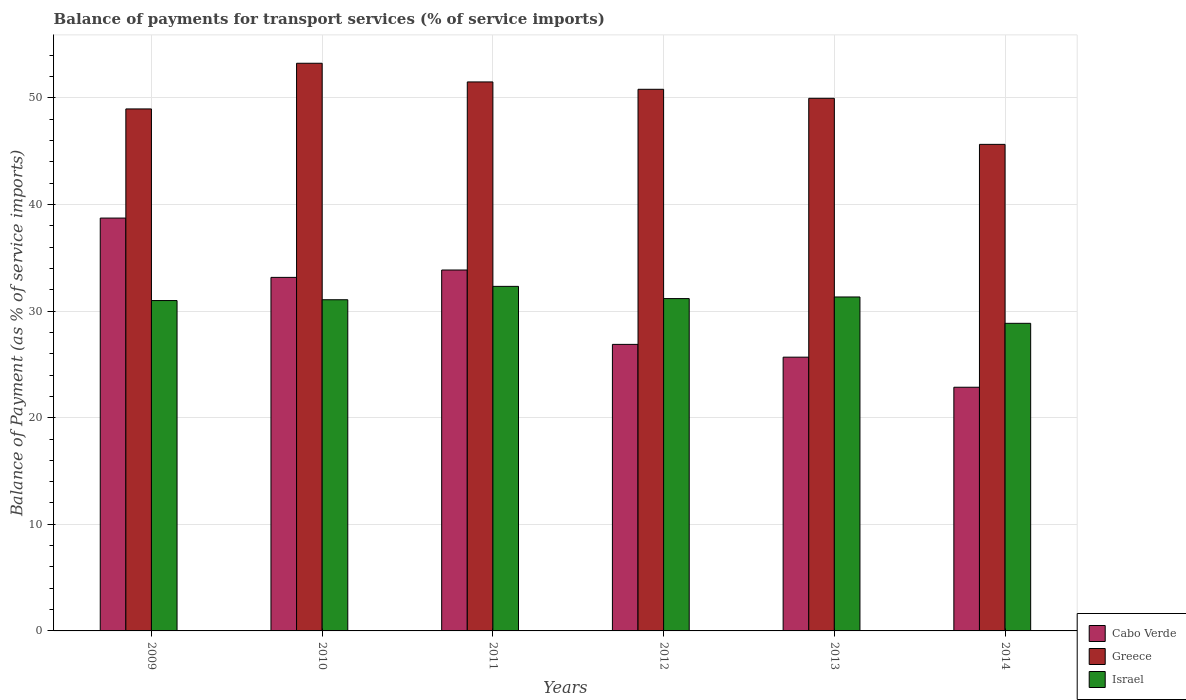How many different coloured bars are there?
Your answer should be very brief. 3. Are the number of bars per tick equal to the number of legend labels?
Your answer should be compact. Yes. What is the label of the 1st group of bars from the left?
Give a very brief answer. 2009. What is the balance of payments for transport services in Israel in 2014?
Provide a succinct answer. 28.85. Across all years, what is the maximum balance of payments for transport services in Cabo Verde?
Ensure brevity in your answer.  38.73. Across all years, what is the minimum balance of payments for transport services in Cabo Verde?
Provide a short and direct response. 22.86. In which year was the balance of payments for transport services in Greece maximum?
Make the answer very short. 2010. In which year was the balance of payments for transport services in Cabo Verde minimum?
Give a very brief answer. 2014. What is the total balance of payments for transport services in Greece in the graph?
Provide a succinct answer. 300.13. What is the difference between the balance of payments for transport services in Greece in 2013 and that in 2014?
Offer a terse response. 4.32. What is the difference between the balance of payments for transport services in Cabo Verde in 2011 and the balance of payments for transport services in Israel in 2014?
Your answer should be compact. 5. What is the average balance of payments for transport services in Cabo Verde per year?
Your answer should be compact. 30.19. In the year 2009, what is the difference between the balance of payments for transport services in Greece and balance of payments for transport services in Cabo Verde?
Offer a very short reply. 10.24. In how many years, is the balance of payments for transport services in Israel greater than 38 %?
Offer a terse response. 0. What is the ratio of the balance of payments for transport services in Greece in 2011 to that in 2014?
Your answer should be compact. 1.13. Is the balance of payments for transport services in Cabo Verde in 2009 less than that in 2011?
Ensure brevity in your answer.  No. What is the difference between the highest and the second highest balance of payments for transport services in Israel?
Give a very brief answer. 1. What is the difference between the highest and the lowest balance of payments for transport services in Israel?
Provide a succinct answer. 3.47. What does the 3rd bar from the right in 2013 represents?
Your answer should be compact. Cabo Verde. How many bars are there?
Your answer should be compact. 18. Are all the bars in the graph horizontal?
Give a very brief answer. No. What is the difference between two consecutive major ticks on the Y-axis?
Your answer should be very brief. 10. Does the graph contain grids?
Ensure brevity in your answer.  Yes. What is the title of the graph?
Your answer should be compact. Balance of payments for transport services (% of service imports). Does "Channel Islands" appear as one of the legend labels in the graph?
Make the answer very short. No. What is the label or title of the Y-axis?
Give a very brief answer. Balance of Payment (as % of service imports). What is the Balance of Payment (as % of service imports) in Cabo Verde in 2009?
Keep it short and to the point. 38.73. What is the Balance of Payment (as % of service imports) in Greece in 2009?
Keep it short and to the point. 48.97. What is the Balance of Payment (as % of service imports) of Israel in 2009?
Your answer should be very brief. 30.99. What is the Balance of Payment (as % of service imports) of Cabo Verde in 2010?
Offer a terse response. 33.16. What is the Balance of Payment (as % of service imports) of Greece in 2010?
Your response must be concise. 53.25. What is the Balance of Payment (as % of service imports) of Israel in 2010?
Your answer should be compact. 31.07. What is the Balance of Payment (as % of service imports) of Cabo Verde in 2011?
Offer a very short reply. 33.86. What is the Balance of Payment (as % of service imports) in Greece in 2011?
Your response must be concise. 51.5. What is the Balance of Payment (as % of service imports) in Israel in 2011?
Give a very brief answer. 32.32. What is the Balance of Payment (as % of service imports) in Cabo Verde in 2012?
Make the answer very short. 26.88. What is the Balance of Payment (as % of service imports) of Greece in 2012?
Provide a succinct answer. 50.81. What is the Balance of Payment (as % of service imports) of Israel in 2012?
Provide a succinct answer. 31.18. What is the Balance of Payment (as % of service imports) of Cabo Verde in 2013?
Provide a short and direct response. 25.68. What is the Balance of Payment (as % of service imports) of Greece in 2013?
Your response must be concise. 49.96. What is the Balance of Payment (as % of service imports) in Israel in 2013?
Make the answer very short. 31.33. What is the Balance of Payment (as % of service imports) in Cabo Verde in 2014?
Offer a terse response. 22.86. What is the Balance of Payment (as % of service imports) in Greece in 2014?
Make the answer very short. 45.64. What is the Balance of Payment (as % of service imports) in Israel in 2014?
Make the answer very short. 28.85. Across all years, what is the maximum Balance of Payment (as % of service imports) of Cabo Verde?
Provide a succinct answer. 38.73. Across all years, what is the maximum Balance of Payment (as % of service imports) in Greece?
Give a very brief answer. 53.25. Across all years, what is the maximum Balance of Payment (as % of service imports) of Israel?
Provide a short and direct response. 32.32. Across all years, what is the minimum Balance of Payment (as % of service imports) in Cabo Verde?
Keep it short and to the point. 22.86. Across all years, what is the minimum Balance of Payment (as % of service imports) of Greece?
Your answer should be very brief. 45.64. Across all years, what is the minimum Balance of Payment (as % of service imports) of Israel?
Provide a short and direct response. 28.85. What is the total Balance of Payment (as % of service imports) in Cabo Verde in the graph?
Ensure brevity in your answer.  181.17. What is the total Balance of Payment (as % of service imports) in Greece in the graph?
Offer a very short reply. 300.13. What is the total Balance of Payment (as % of service imports) in Israel in the graph?
Make the answer very short. 185.74. What is the difference between the Balance of Payment (as % of service imports) of Cabo Verde in 2009 and that in 2010?
Provide a short and direct response. 5.56. What is the difference between the Balance of Payment (as % of service imports) of Greece in 2009 and that in 2010?
Make the answer very short. -4.28. What is the difference between the Balance of Payment (as % of service imports) of Israel in 2009 and that in 2010?
Offer a very short reply. -0.08. What is the difference between the Balance of Payment (as % of service imports) in Cabo Verde in 2009 and that in 2011?
Give a very brief answer. 4.87. What is the difference between the Balance of Payment (as % of service imports) of Greece in 2009 and that in 2011?
Keep it short and to the point. -2.53. What is the difference between the Balance of Payment (as % of service imports) of Israel in 2009 and that in 2011?
Provide a short and direct response. -1.33. What is the difference between the Balance of Payment (as % of service imports) in Cabo Verde in 2009 and that in 2012?
Provide a short and direct response. 11.85. What is the difference between the Balance of Payment (as % of service imports) of Greece in 2009 and that in 2012?
Your response must be concise. -1.84. What is the difference between the Balance of Payment (as % of service imports) of Israel in 2009 and that in 2012?
Your answer should be compact. -0.18. What is the difference between the Balance of Payment (as % of service imports) of Cabo Verde in 2009 and that in 2013?
Offer a very short reply. 13.05. What is the difference between the Balance of Payment (as % of service imports) of Greece in 2009 and that in 2013?
Make the answer very short. -1. What is the difference between the Balance of Payment (as % of service imports) in Israel in 2009 and that in 2013?
Provide a short and direct response. -0.34. What is the difference between the Balance of Payment (as % of service imports) in Cabo Verde in 2009 and that in 2014?
Give a very brief answer. 15.87. What is the difference between the Balance of Payment (as % of service imports) of Greece in 2009 and that in 2014?
Provide a short and direct response. 3.32. What is the difference between the Balance of Payment (as % of service imports) of Israel in 2009 and that in 2014?
Your answer should be very brief. 2.14. What is the difference between the Balance of Payment (as % of service imports) in Cabo Verde in 2010 and that in 2011?
Give a very brief answer. -0.69. What is the difference between the Balance of Payment (as % of service imports) in Greece in 2010 and that in 2011?
Offer a very short reply. 1.75. What is the difference between the Balance of Payment (as % of service imports) in Israel in 2010 and that in 2011?
Keep it short and to the point. -1.25. What is the difference between the Balance of Payment (as % of service imports) of Cabo Verde in 2010 and that in 2012?
Keep it short and to the point. 6.28. What is the difference between the Balance of Payment (as % of service imports) of Greece in 2010 and that in 2012?
Your response must be concise. 2.44. What is the difference between the Balance of Payment (as % of service imports) in Israel in 2010 and that in 2012?
Offer a very short reply. -0.11. What is the difference between the Balance of Payment (as % of service imports) of Cabo Verde in 2010 and that in 2013?
Offer a terse response. 7.48. What is the difference between the Balance of Payment (as % of service imports) in Greece in 2010 and that in 2013?
Provide a succinct answer. 3.29. What is the difference between the Balance of Payment (as % of service imports) in Israel in 2010 and that in 2013?
Provide a short and direct response. -0.26. What is the difference between the Balance of Payment (as % of service imports) in Cabo Verde in 2010 and that in 2014?
Your answer should be very brief. 10.31. What is the difference between the Balance of Payment (as % of service imports) in Greece in 2010 and that in 2014?
Provide a short and direct response. 7.61. What is the difference between the Balance of Payment (as % of service imports) of Israel in 2010 and that in 2014?
Your answer should be compact. 2.21. What is the difference between the Balance of Payment (as % of service imports) of Cabo Verde in 2011 and that in 2012?
Offer a very short reply. 6.98. What is the difference between the Balance of Payment (as % of service imports) in Greece in 2011 and that in 2012?
Make the answer very short. 0.69. What is the difference between the Balance of Payment (as % of service imports) of Israel in 2011 and that in 2012?
Keep it short and to the point. 1.15. What is the difference between the Balance of Payment (as % of service imports) in Cabo Verde in 2011 and that in 2013?
Provide a succinct answer. 8.18. What is the difference between the Balance of Payment (as % of service imports) of Greece in 2011 and that in 2013?
Provide a succinct answer. 1.54. What is the difference between the Balance of Payment (as % of service imports) of Israel in 2011 and that in 2013?
Provide a short and direct response. 1. What is the difference between the Balance of Payment (as % of service imports) in Cabo Verde in 2011 and that in 2014?
Keep it short and to the point. 11. What is the difference between the Balance of Payment (as % of service imports) of Greece in 2011 and that in 2014?
Offer a terse response. 5.86. What is the difference between the Balance of Payment (as % of service imports) in Israel in 2011 and that in 2014?
Your response must be concise. 3.47. What is the difference between the Balance of Payment (as % of service imports) of Cabo Verde in 2012 and that in 2013?
Provide a succinct answer. 1.2. What is the difference between the Balance of Payment (as % of service imports) in Greece in 2012 and that in 2013?
Keep it short and to the point. 0.85. What is the difference between the Balance of Payment (as % of service imports) in Israel in 2012 and that in 2013?
Make the answer very short. -0.15. What is the difference between the Balance of Payment (as % of service imports) of Cabo Verde in 2012 and that in 2014?
Your response must be concise. 4.02. What is the difference between the Balance of Payment (as % of service imports) in Greece in 2012 and that in 2014?
Keep it short and to the point. 5.17. What is the difference between the Balance of Payment (as % of service imports) in Israel in 2012 and that in 2014?
Offer a very short reply. 2.32. What is the difference between the Balance of Payment (as % of service imports) of Cabo Verde in 2013 and that in 2014?
Ensure brevity in your answer.  2.82. What is the difference between the Balance of Payment (as % of service imports) of Greece in 2013 and that in 2014?
Your answer should be very brief. 4.32. What is the difference between the Balance of Payment (as % of service imports) of Israel in 2013 and that in 2014?
Offer a terse response. 2.47. What is the difference between the Balance of Payment (as % of service imports) of Cabo Verde in 2009 and the Balance of Payment (as % of service imports) of Greece in 2010?
Keep it short and to the point. -14.52. What is the difference between the Balance of Payment (as % of service imports) of Cabo Verde in 2009 and the Balance of Payment (as % of service imports) of Israel in 2010?
Keep it short and to the point. 7.66. What is the difference between the Balance of Payment (as % of service imports) in Greece in 2009 and the Balance of Payment (as % of service imports) in Israel in 2010?
Provide a succinct answer. 17.9. What is the difference between the Balance of Payment (as % of service imports) in Cabo Verde in 2009 and the Balance of Payment (as % of service imports) in Greece in 2011?
Give a very brief answer. -12.77. What is the difference between the Balance of Payment (as % of service imports) of Cabo Verde in 2009 and the Balance of Payment (as % of service imports) of Israel in 2011?
Your answer should be very brief. 6.41. What is the difference between the Balance of Payment (as % of service imports) in Greece in 2009 and the Balance of Payment (as % of service imports) in Israel in 2011?
Provide a succinct answer. 16.64. What is the difference between the Balance of Payment (as % of service imports) in Cabo Verde in 2009 and the Balance of Payment (as % of service imports) in Greece in 2012?
Your response must be concise. -12.08. What is the difference between the Balance of Payment (as % of service imports) in Cabo Verde in 2009 and the Balance of Payment (as % of service imports) in Israel in 2012?
Keep it short and to the point. 7.55. What is the difference between the Balance of Payment (as % of service imports) of Greece in 2009 and the Balance of Payment (as % of service imports) of Israel in 2012?
Keep it short and to the point. 17.79. What is the difference between the Balance of Payment (as % of service imports) of Cabo Verde in 2009 and the Balance of Payment (as % of service imports) of Greece in 2013?
Offer a terse response. -11.24. What is the difference between the Balance of Payment (as % of service imports) in Cabo Verde in 2009 and the Balance of Payment (as % of service imports) in Israel in 2013?
Keep it short and to the point. 7.4. What is the difference between the Balance of Payment (as % of service imports) of Greece in 2009 and the Balance of Payment (as % of service imports) of Israel in 2013?
Ensure brevity in your answer.  17.64. What is the difference between the Balance of Payment (as % of service imports) of Cabo Verde in 2009 and the Balance of Payment (as % of service imports) of Greece in 2014?
Make the answer very short. -6.91. What is the difference between the Balance of Payment (as % of service imports) of Cabo Verde in 2009 and the Balance of Payment (as % of service imports) of Israel in 2014?
Keep it short and to the point. 9.87. What is the difference between the Balance of Payment (as % of service imports) in Greece in 2009 and the Balance of Payment (as % of service imports) in Israel in 2014?
Your response must be concise. 20.11. What is the difference between the Balance of Payment (as % of service imports) of Cabo Verde in 2010 and the Balance of Payment (as % of service imports) of Greece in 2011?
Make the answer very short. -18.33. What is the difference between the Balance of Payment (as % of service imports) in Cabo Verde in 2010 and the Balance of Payment (as % of service imports) in Israel in 2011?
Your answer should be compact. 0.84. What is the difference between the Balance of Payment (as % of service imports) of Greece in 2010 and the Balance of Payment (as % of service imports) of Israel in 2011?
Keep it short and to the point. 20.93. What is the difference between the Balance of Payment (as % of service imports) in Cabo Verde in 2010 and the Balance of Payment (as % of service imports) in Greece in 2012?
Make the answer very short. -17.64. What is the difference between the Balance of Payment (as % of service imports) of Cabo Verde in 2010 and the Balance of Payment (as % of service imports) of Israel in 2012?
Your answer should be very brief. 1.99. What is the difference between the Balance of Payment (as % of service imports) of Greece in 2010 and the Balance of Payment (as % of service imports) of Israel in 2012?
Keep it short and to the point. 22.08. What is the difference between the Balance of Payment (as % of service imports) in Cabo Verde in 2010 and the Balance of Payment (as % of service imports) in Greece in 2013?
Your answer should be compact. -16.8. What is the difference between the Balance of Payment (as % of service imports) in Cabo Verde in 2010 and the Balance of Payment (as % of service imports) in Israel in 2013?
Keep it short and to the point. 1.84. What is the difference between the Balance of Payment (as % of service imports) of Greece in 2010 and the Balance of Payment (as % of service imports) of Israel in 2013?
Your answer should be compact. 21.92. What is the difference between the Balance of Payment (as % of service imports) of Cabo Verde in 2010 and the Balance of Payment (as % of service imports) of Greece in 2014?
Your answer should be very brief. -12.48. What is the difference between the Balance of Payment (as % of service imports) of Cabo Verde in 2010 and the Balance of Payment (as % of service imports) of Israel in 2014?
Keep it short and to the point. 4.31. What is the difference between the Balance of Payment (as % of service imports) of Greece in 2010 and the Balance of Payment (as % of service imports) of Israel in 2014?
Your response must be concise. 24.4. What is the difference between the Balance of Payment (as % of service imports) of Cabo Verde in 2011 and the Balance of Payment (as % of service imports) of Greece in 2012?
Make the answer very short. -16.95. What is the difference between the Balance of Payment (as % of service imports) in Cabo Verde in 2011 and the Balance of Payment (as % of service imports) in Israel in 2012?
Provide a short and direct response. 2.68. What is the difference between the Balance of Payment (as % of service imports) in Greece in 2011 and the Balance of Payment (as % of service imports) in Israel in 2012?
Offer a very short reply. 20.32. What is the difference between the Balance of Payment (as % of service imports) in Cabo Verde in 2011 and the Balance of Payment (as % of service imports) in Greece in 2013?
Give a very brief answer. -16.11. What is the difference between the Balance of Payment (as % of service imports) in Cabo Verde in 2011 and the Balance of Payment (as % of service imports) in Israel in 2013?
Your answer should be compact. 2.53. What is the difference between the Balance of Payment (as % of service imports) of Greece in 2011 and the Balance of Payment (as % of service imports) of Israel in 2013?
Make the answer very short. 20.17. What is the difference between the Balance of Payment (as % of service imports) of Cabo Verde in 2011 and the Balance of Payment (as % of service imports) of Greece in 2014?
Provide a succinct answer. -11.79. What is the difference between the Balance of Payment (as % of service imports) in Cabo Verde in 2011 and the Balance of Payment (as % of service imports) in Israel in 2014?
Ensure brevity in your answer.  5. What is the difference between the Balance of Payment (as % of service imports) in Greece in 2011 and the Balance of Payment (as % of service imports) in Israel in 2014?
Ensure brevity in your answer.  22.64. What is the difference between the Balance of Payment (as % of service imports) of Cabo Verde in 2012 and the Balance of Payment (as % of service imports) of Greece in 2013?
Your answer should be very brief. -23.08. What is the difference between the Balance of Payment (as % of service imports) in Cabo Verde in 2012 and the Balance of Payment (as % of service imports) in Israel in 2013?
Your answer should be very brief. -4.45. What is the difference between the Balance of Payment (as % of service imports) in Greece in 2012 and the Balance of Payment (as % of service imports) in Israel in 2013?
Provide a succinct answer. 19.48. What is the difference between the Balance of Payment (as % of service imports) in Cabo Verde in 2012 and the Balance of Payment (as % of service imports) in Greece in 2014?
Provide a succinct answer. -18.76. What is the difference between the Balance of Payment (as % of service imports) of Cabo Verde in 2012 and the Balance of Payment (as % of service imports) of Israel in 2014?
Your answer should be very brief. -1.97. What is the difference between the Balance of Payment (as % of service imports) in Greece in 2012 and the Balance of Payment (as % of service imports) in Israel in 2014?
Ensure brevity in your answer.  21.95. What is the difference between the Balance of Payment (as % of service imports) in Cabo Verde in 2013 and the Balance of Payment (as % of service imports) in Greece in 2014?
Provide a short and direct response. -19.96. What is the difference between the Balance of Payment (as % of service imports) of Cabo Verde in 2013 and the Balance of Payment (as % of service imports) of Israel in 2014?
Your response must be concise. -3.17. What is the difference between the Balance of Payment (as % of service imports) of Greece in 2013 and the Balance of Payment (as % of service imports) of Israel in 2014?
Provide a short and direct response. 21.11. What is the average Balance of Payment (as % of service imports) of Cabo Verde per year?
Provide a succinct answer. 30.19. What is the average Balance of Payment (as % of service imports) in Greece per year?
Your answer should be compact. 50.02. What is the average Balance of Payment (as % of service imports) of Israel per year?
Your answer should be compact. 30.96. In the year 2009, what is the difference between the Balance of Payment (as % of service imports) of Cabo Verde and Balance of Payment (as % of service imports) of Greece?
Keep it short and to the point. -10.24. In the year 2009, what is the difference between the Balance of Payment (as % of service imports) in Cabo Verde and Balance of Payment (as % of service imports) in Israel?
Offer a very short reply. 7.74. In the year 2009, what is the difference between the Balance of Payment (as % of service imports) of Greece and Balance of Payment (as % of service imports) of Israel?
Ensure brevity in your answer.  17.98. In the year 2010, what is the difference between the Balance of Payment (as % of service imports) of Cabo Verde and Balance of Payment (as % of service imports) of Greece?
Offer a terse response. -20.09. In the year 2010, what is the difference between the Balance of Payment (as % of service imports) of Cabo Verde and Balance of Payment (as % of service imports) of Israel?
Give a very brief answer. 2.1. In the year 2010, what is the difference between the Balance of Payment (as % of service imports) of Greece and Balance of Payment (as % of service imports) of Israel?
Your response must be concise. 22.18. In the year 2011, what is the difference between the Balance of Payment (as % of service imports) in Cabo Verde and Balance of Payment (as % of service imports) in Greece?
Ensure brevity in your answer.  -17.64. In the year 2011, what is the difference between the Balance of Payment (as % of service imports) in Cabo Verde and Balance of Payment (as % of service imports) in Israel?
Ensure brevity in your answer.  1.53. In the year 2011, what is the difference between the Balance of Payment (as % of service imports) in Greece and Balance of Payment (as % of service imports) in Israel?
Your answer should be compact. 19.18. In the year 2012, what is the difference between the Balance of Payment (as % of service imports) of Cabo Verde and Balance of Payment (as % of service imports) of Greece?
Make the answer very short. -23.93. In the year 2012, what is the difference between the Balance of Payment (as % of service imports) of Cabo Verde and Balance of Payment (as % of service imports) of Israel?
Make the answer very short. -4.3. In the year 2012, what is the difference between the Balance of Payment (as % of service imports) of Greece and Balance of Payment (as % of service imports) of Israel?
Your answer should be very brief. 19.63. In the year 2013, what is the difference between the Balance of Payment (as % of service imports) in Cabo Verde and Balance of Payment (as % of service imports) in Greece?
Give a very brief answer. -24.28. In the year 2013, what is the difference between the Balance of Payment (as % of service imports) of Cabo Verde and Balance of Payment (as % of service imports) of Israel?
Ensure brevity in your answer.  -5.65. In the year 2013, what is the difference between the Balance of Payment (as % of service imports) in Greece and Balance of Payment (as % of service imports) in Israel?
Your answer should be compact. 18.64. In the year 2014, what is the difference between the Balance of Payment (as % of service imports) in Cabo Verde and Balance of Payment (as % of service imports) in Greece?
Your answer should be very brief. -22.78. In the year 2014, what is the difference between the Balance of Payment (as % of service imports) in Cabo Verde and Balance of Payment (as % of service imports) in Israel?
Provide a short and direct response. -6. In the year 2014, what is the difference between the Balance of Payment (as % of service imports) in Greece and Balance of Payment (as % of service imports) in Israel?
Your answer should be very brief. 16.79. What is the ratio of the Balance of Payment (as % of service imports) of Cabo Verde in 2009 to that in 2010?
Make the answer very short. 1.17. What is the ratio of the Balance of Payment (as % of service imports) in Greece in 2009 to that in 2010?
Keep it short and to the point. 0.92. What is the ratio of the Balance of Payment (as % of service imports) of Cabo Verde in 2009 to that in 2011?
Make the answer very short. 1.14. What is the ratio of the Balance of Payment (as % of service imports) of Greece in 2009 to that in 2011?
Provide a short and direct response. 0.95. What is the ratio of the Balance of Payment (as % of service imports) in Israel in 2009 to that in 2011?
Offer a very short reply. 0.96. What is the ratio of the Balance of Payment (as % of service imports) in Cabo Verde in 2009 to that in 2012?
Make the answer very short. 1.44. What is the ratio of the Balance of Payment (as % of service imports) of Greece in 2009 to that in 2012?
Give a very brief answer. 0.96. What is the ratio of the Balance of Payment (as % of service imports) in Cabo Verde in 2009 to that in 2013?
Your answer should be compact. 1.51. What is the ratio of the Balance of Payment (as % of service imports) in Israel in 2009 to that in 2013?
Give a very brief answer. 0.99. What is the ratio of the Balance of Payment (as % of service imports) in Cabo Verde in 2009 to that in 2014?
Give a very brief answer. 1.69. What is the ratio of the Balance of Payment (as % of service imports) in Greece in 2009 to that in 2014?
Ensure brevity in your answer.  1.07. What is the ratio of the Balance of Payment (as % of service imports) of Israel in 2009 to that in 2014?
Provide a succinct answer. 1.07. What is the ratio of the Balance of Payment (as % of service imports) in Cabo Verde in 2010 to that in 2011?
Offer a very short reply. 0.98. What is the ratio of the Balance of Payment (as % of service imports) in Greece in 2010 to that in 2011?
Make the answer very short. 1.03. What is the ratio of the Balance of Payment (as % of service imports) in Israel in 2010 to that in 2011?
Your response must be concise. 0.96. What is the ratio of the Balance of Payment (as % of service imports) in Cabo Verde in 2010 to that in 2012?
Provide a succinct answer. 1.23. What is the ratio of the Balance of Payment (as % of service imports) of Greece in 2010 to that in 2012?
Provide a succinct answer. 1.05. What is the ratio of the Balance of Payment (as % of service imports) in Cabo Verde in 2010 to that in 2013?
Provide a short and direct response. 1.29. What is the ratio of the Balance of Payment (as % of service imports) of Greece in 2010 to that in 2013?
Provide a succinct answer. 1.07. What is the ratio of the Balance of Payment (as % of service imports) in Cabo Verde in 2010 to that in 2014?
Provide a short and direct response. 1.45. What is the ratio of the Balance of Payment (as % of service imports) in Greece in 2010 to that in 2014?
Your response must be concise. 1.17. What is the ratio of the Balance of Payment (as % of service imports) in Israel in 2010 to that in 2014?
Make the answer very short. 1.08. What is the ratio of the Balance of Payment (as % of service imports) of Cabo Verde in 2011 to that in 2012?
Your answer should be very brief. 1.26. What is the ratio of the Balance of Payment (as % of service imports) of Greece in 2011 to that in 2012?
Provide a short and direct response. 1.01. What is the ratio of the Balance of Payment (as % of service imports) in Israel in 2011 to that in 2012?
Offer a very short reply. 1.04. What is the ratio of the Balance of Payment (as % of service imports) of Cabo Verde in 2011 to that in 2013?
Provide a succinct answer. 1.32. What is the ratio of the Balance of Payment (as % of service imports) in Greece in 2011 to that in 2013?
Provide a short and direct response. 1.03. What is the ratio of the Balance of Payment (as % of service imports) in Israel in 2011 to that in 2013?
Make the answer very short. 1.03. What is the ratio of the Balance of Payment (as % of service imports) of Cabo Verde in 2011 to that in 2014?
Your answer should be very brief. 1.48. What is the ratio of the Balance of Payment (as % of service imports) of Greece in 2011 to that in 2014?
Ensure brevity in your answer.  1.13. What is the ratio of the Balance of Payment (as % of service imports) in Israel in 2011 to that in 2014?
Make the answer very short. 1.12. What is the ratio of the Balance of Payment (as % of service imports) in Cabo Verde in 2012 to that in 2013?
Ensure brevity in your answer.  1.05. What is the ratio of the Balance of Payment (as % of service imports) in Greece in 2012 to that in 2013?
Keep it short and to the point. 1.02. What is the ratio of the Balance of Payment (as % of service imports) in Cabo Verde in 2012 to that in 2014?
Ensure brevity in your answer.  1.18. What is the ratio of the Balance of Payment (as % of service imports) of Greece in 2012 to that in 2014?
Offer a terse response. 1.11. What is the ratio of the Balance of Payment (as % of service imports) in Israel in 2012 to that in 2014?
Provide a short and direct response. 1.08. What is the ratio of the Balance of Payment (as % of service imports) in Cabo Verde in 2013 to that in 2014?
Your answer should be very brief. 1.12. What is the ratio of the Balance of Payment (as % of service imports) in Greece in 2013 to that in 2014?
Keep it short and to the point. 1.09. What is the ratio of the Balance of Payment (as % of service imports) of Israel in 2013 to that in 2014?
Keep it short and to the point. 1.09. What is the difference between the highest and the second highest Balance of Payment (as % of service imports) of Cabo Verde?
Your response must be concise. 4.87. What is the difference between the highest and the second highest Balance of Payment (as % of service imports) in Greece?
Offer a terse response. 1.75. What is the difference between the highest and the second highest Balance of Payment (as % of service imports) in Israel?
Ensure brevity in your answer.  1. What is the difference between the highest and the lowest Balance of Payment (as % of service imports) in Cabo Verde?
Your answer should be very brief. 15.87. What is the difference between the highest and the lowest Balance of Payment (as % of service imports) of Greece?
Ensure brevity in your answer.  7.61. What is the difference between the highest and the lowest Balance of Payment (as % of service imports) in Israel?
Provide a succinct answer. 3.47. 